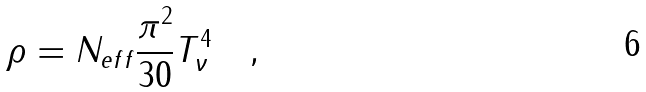<formula> <loc_0><loc_0><loc_500><loc_500>\rho = N _ { e f f } \frac { \pi ^ { 2 } } { 3 0 } T ^ { 4 } _ { \nu } \quad ,</formula> 